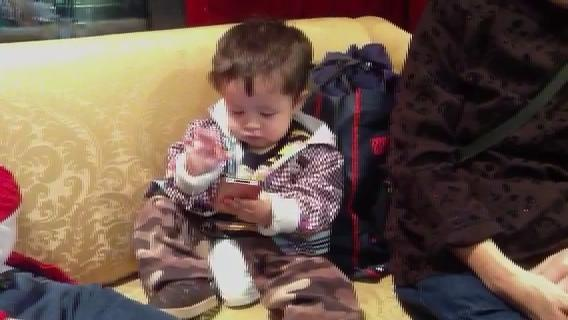What holiday is likely being celebrated here? christmas 